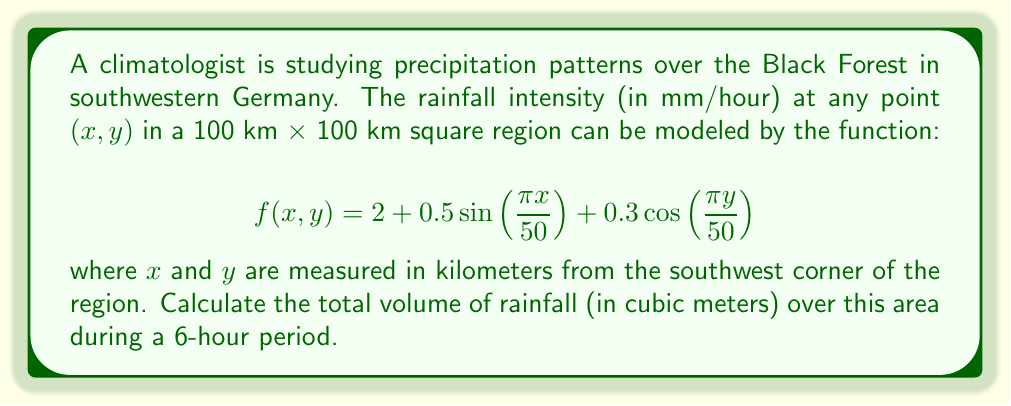Help me with this question. To solve this problem, we need to use a double integral to find the volume under the surface described by $f(x,y)$ over the given region, and then multiply by the time period.

1. Set up the double integral:
   $$V = \int_0^{100} \int_0^{100} f(x,y) \,dy\,dx$$

2. Substitute the function:
   $$V = \int_0^{100} \int_0^{100} [2 + 0.5\sin(\frac{\pi x}{50}) + 0.3\cos(\frac{\pi y}{50})] \,dy\,dx$$

3. Integrate with respect to y:
   $$V = \int_0^{100} [2y + 0.5y\sin(\frac{\pi x}{50}) + \frac{15}{\pi}\sin(\frac{\pi y}{50})]_0^{100} \,dx$$
   
   $$V = \int_0^{100} [200 + 50\sin(\frac{\pi x}{50}) + \frac{15}{\pi}(\sin(2\pi) - \sin(0))] \,dx$$
   
   $$V = \int_0^{100} [200 + 50\sin(\frac{\pi x}{50})] \,dx$$

4. Integrate with respect to x:
   $$V = [200x - \frac{2500}{\pi}\cos(\frac{\pi x}{50})]_0^{100}$$
   
   $$V = 20000 - \frac{2500}{\pi}[\cos(2\pi) - \cos(0)]$$
   
   $$V = 20000 \text{ km}^2 \cdot \text{mm}$$

5. Convert to cubic meters:
   $$V = 20000 \cdot 10^6 \text{ m}^2 \cdot 10^{-3} \text{ m} = 2 \cdot 10^7 \text{ m}^3$$

6. Multiply by the time period (6 hours):
   $$V_{\text{total}} = 2 \cdot 10^7 \text{ m}^3 \cdot 6 = 1.2 \cdot 10^8 \text{ m}^3$$
Answer: $1.2 \cdot 10^8 \text{ m}^3$ 